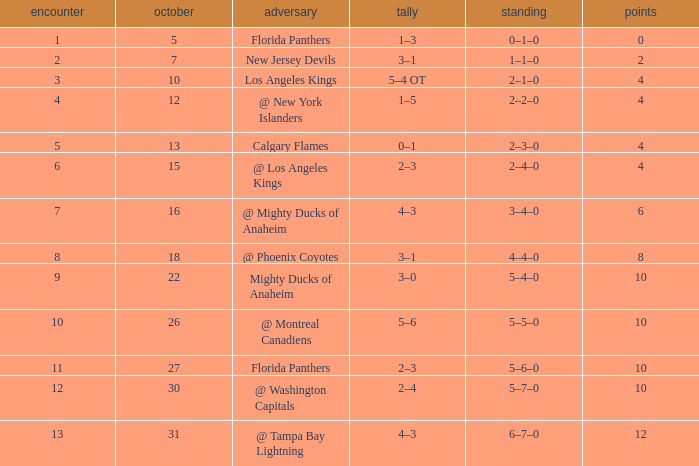What team has a score of 2 3–1. 